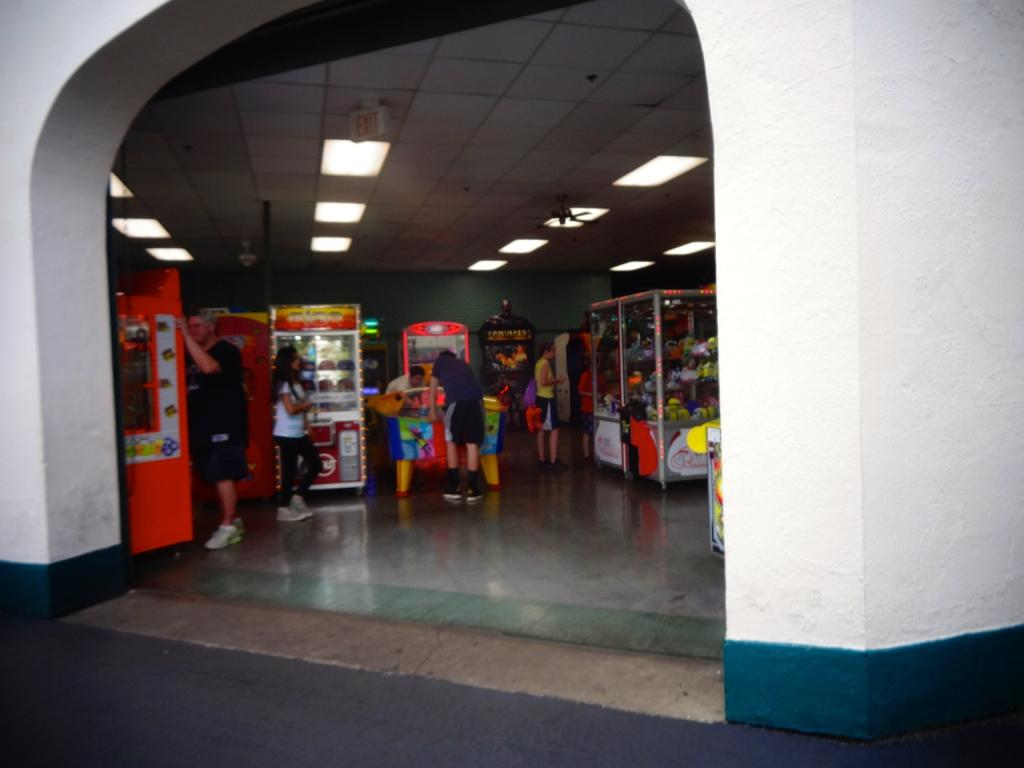What is the main structure visible in the image? There is a building in the image. What can be found inside the building? Inside the building, there are food stalls. Are there any people present in the image? Yes, there are people standing inside the building. What type of face can be seen on the building's facade in the image? There is no face visible on the building's facade in the image. Is the image taken during the night? The provided facts do not mention the time of day, so we cannot determine if the image was taken during the night. 